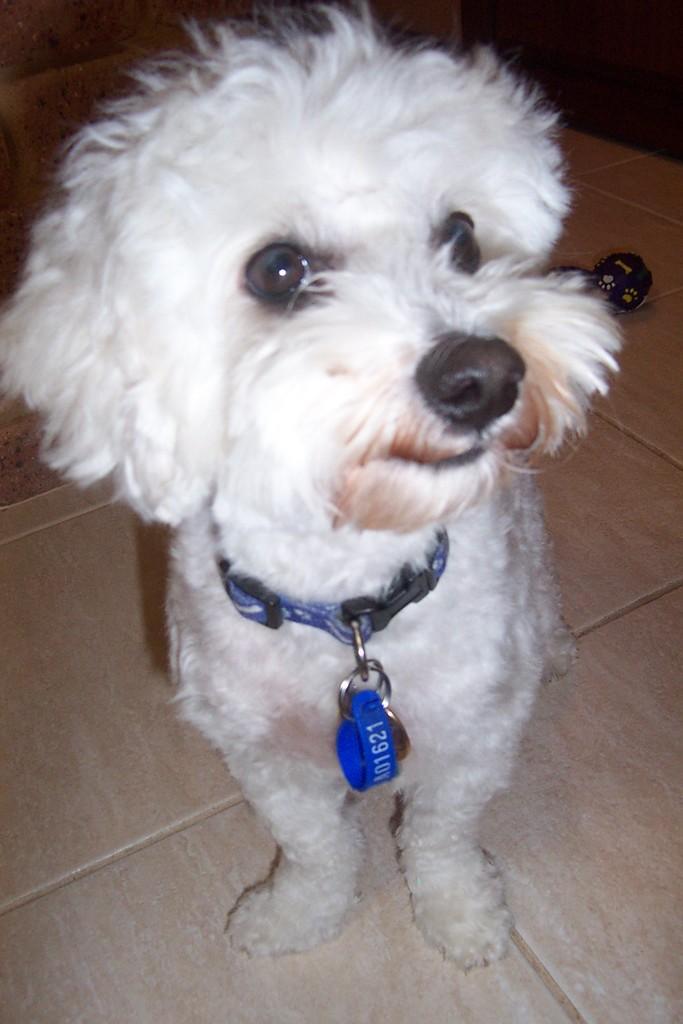How would you summarize this image in a sentence or two? In this image I can see a dog in white color. I can also see a blue color belt. 